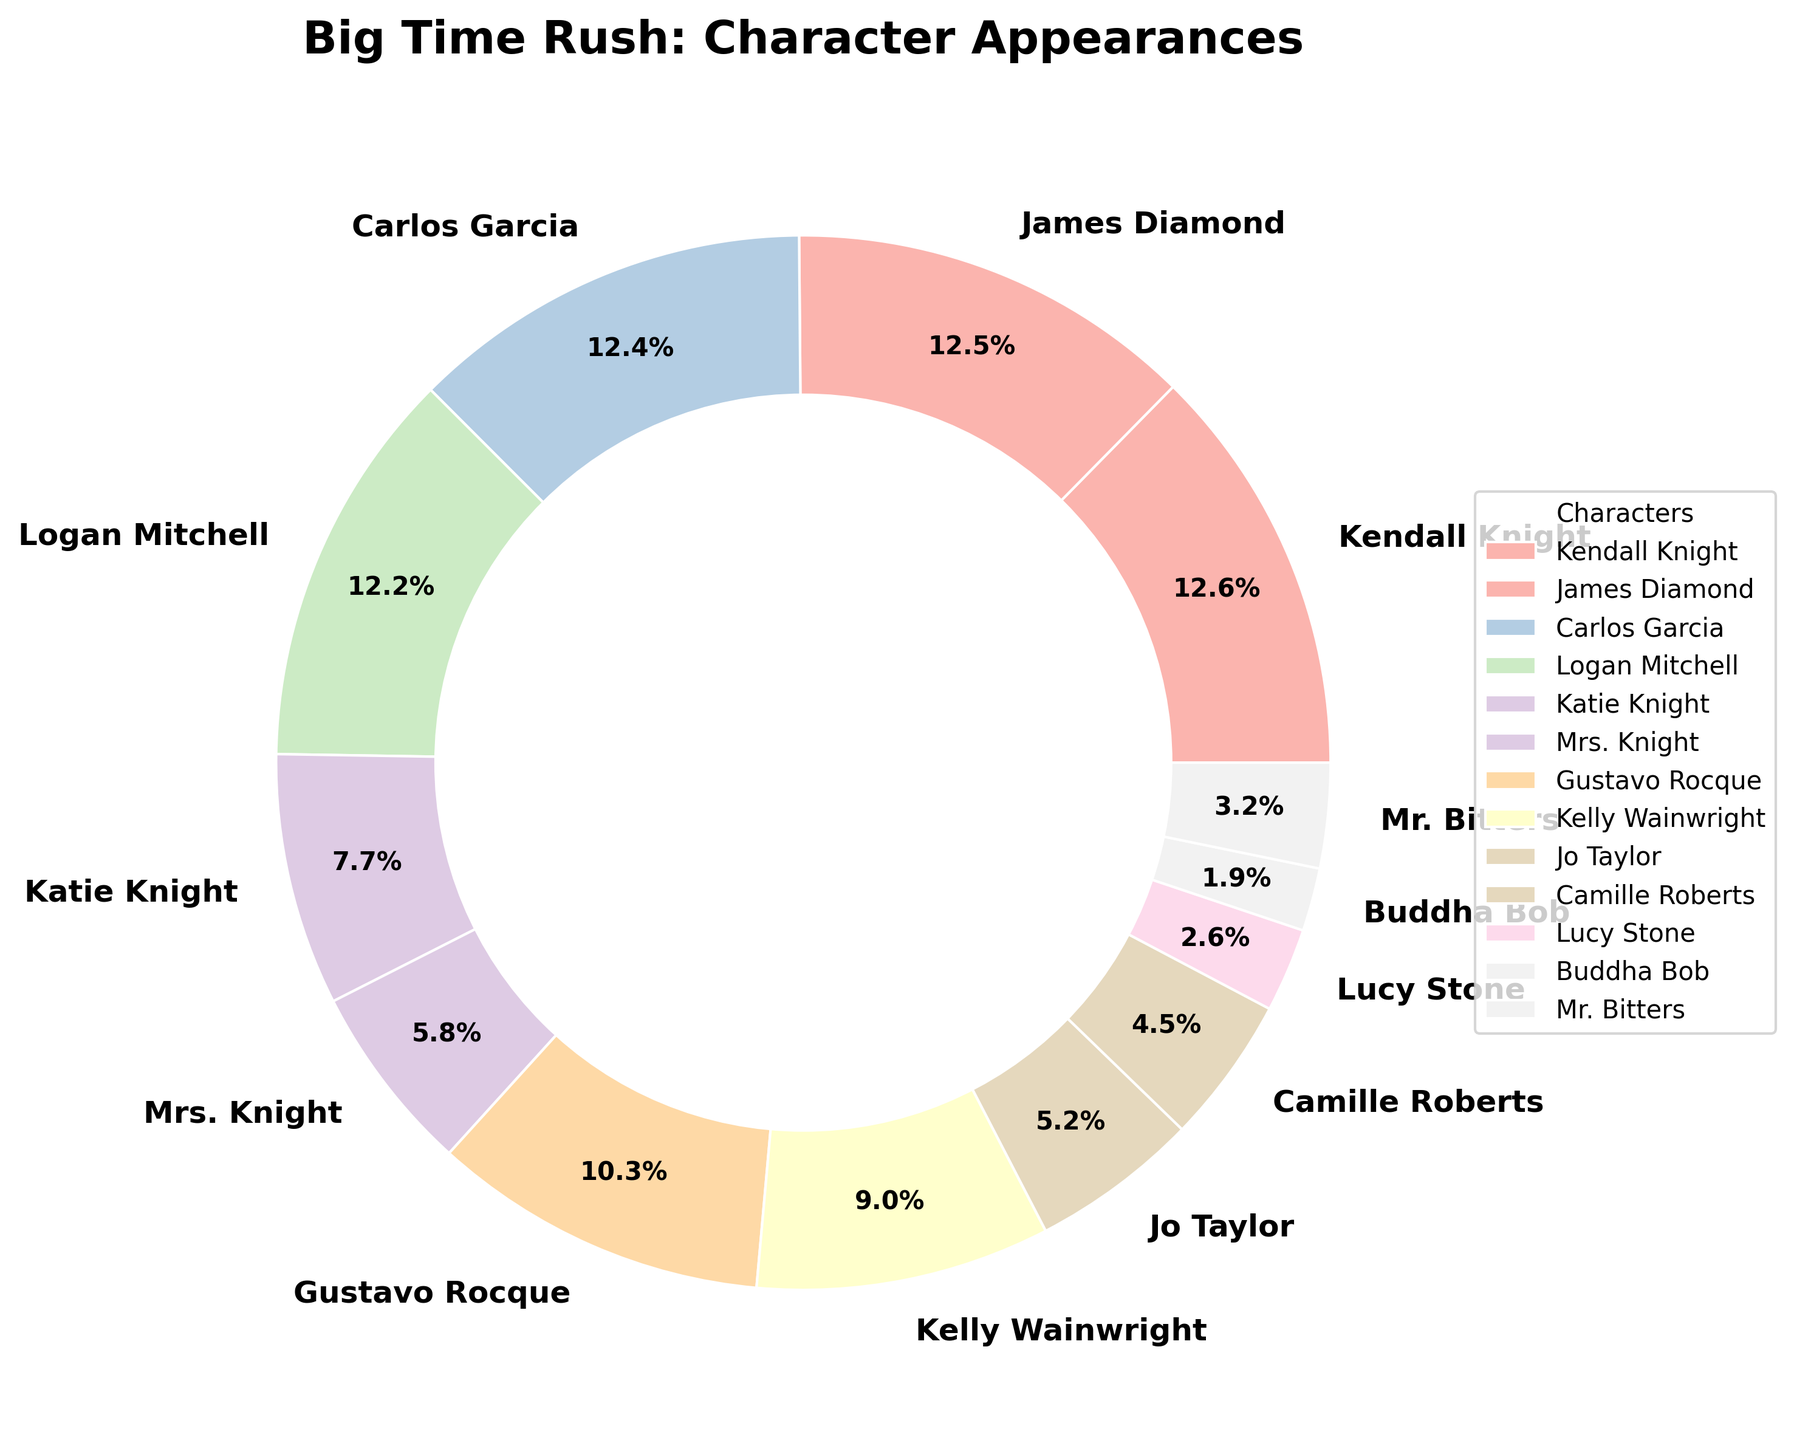Which character appears in the highest percentage of episodes? Kendall Knight appears in 98% of episodes, which is the highest percentage.
Answer: Kendall Knight Which characters appear more frequently than Katie Knight? Kendall Knight (98%), James Diamond (97%), Carlos Garcia (96%), Logan Mitchell (95%), Gustavo Rocque (80%), and Kelly Wainwright (70%) all have higher percentages than Katie Knight (60%).
Answer: Kendall Knight, James Diamond, Carlos Garcia, Logan Mitchell, Gustavo Rocque, Kelly Wainwright How many characters appear in more than 50% of episodes? Comparing the percentages, Kendall Knight, James Diamond, Carlos Garcia, Logan Mitchell, Katie Knight, Gustavo Rocque, and Kelly Wainwright all appear in more than 50% of episodes. This makes a total of 7 characters.
Answer: 7 What's the percentage difference between the most and least frequently appearing characters? Kendall Knight appears in 98% of episodes, and Buddha Bob appears in 15%. The difference is 98% - 15% = 83%.
Answer: 83% Who appears in more episodes: Jo Taylor or Camille Roberts? Jo Taylor appears in 40% of episodes, while Camille Roberts appears in 35%. So, Jo Taylor appears in more episodes.
Answer: Jo Taylor Compare the percentages of James Diamond and Logan Mitchell. Who appears more and by what percentage? James Diamond appears in 97% of episodes and Logan Mitchell in 95%. The difference is 97% - 95% = 2%. James Diamond appears in 2% more episodes than Logan Mitchell.
Answer: James Diamond, 2% Which characters appear in less than 30% of episodes? From the data, Lucy Stone (20%), Buddha Bob (15%), and Mr. Bitters (25%) all appear in less than 30% of episodes.
Answer: Lucy Stone, Buddha Bob, Mr. Bitters What's the combined appearance percentage of the Knight family (Kendall Knight, Katie Knight, and Mrs. Knight)? Adding the percentages of Kendall Knight (98%), Katie Knight (60%), and Mrs. Knight (45%), the combined appearance is 98% + 60% + 45% = 203%.
Answer: 203% Compare the appearance of Gustavo Rocque and Kelly Wainwright to see who appears more and by what difference. Gustavo Rocque appears in 80% of episodes while Kelly Wainwright appears in 70%. The difference is 80% - 70% = 10%. Gustavo Rocque appears in 10% more episodes than Kelly Wainwright.
Answer: Gustavo Rocque, 10% What's the average percentage appearance of the main band members (Kendall Knight, James Diamond, Carlos Garcia, Logan Mitchell)? The percentages are Kendall Knight (98%), James Diamond (97%), Carlos Garcia (96%), Logan Mitchell (95%). The average is (98% + 97% + 96% + 95%) / 4 = 96.5%.
Answer: 96.5% 